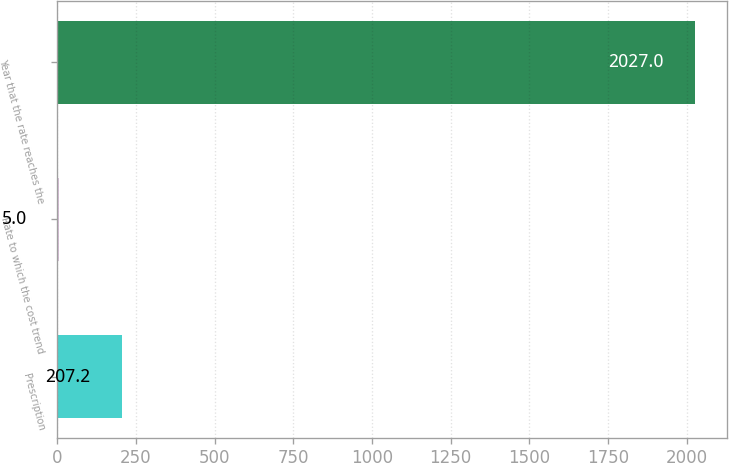Convert chart. <chart><loc_0><loc_0><loc_500><loc_500><bar_chart><fcel>Prescription<fcel>Rate to which the cost trend<fcel>Year that the rate reaches the<nl><fcel>207.2<fcel>5<fcel>2027<nl></chart> 